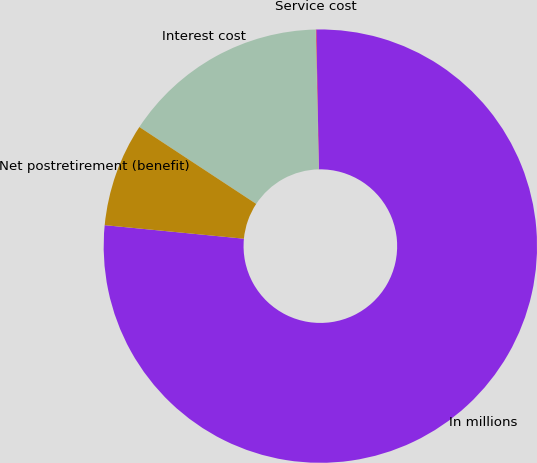<chart> <loc_0><loc_0><loc_500><loc_500><pie_chart><fcel>In millions<fcel>Service cost<fcel>Interest cost<fcel>Net postretirement (benefit)<nl><fcel>76.84%<fcel>0.04%<fcel>15.4%<fcel>7.72%<nl></chart> 